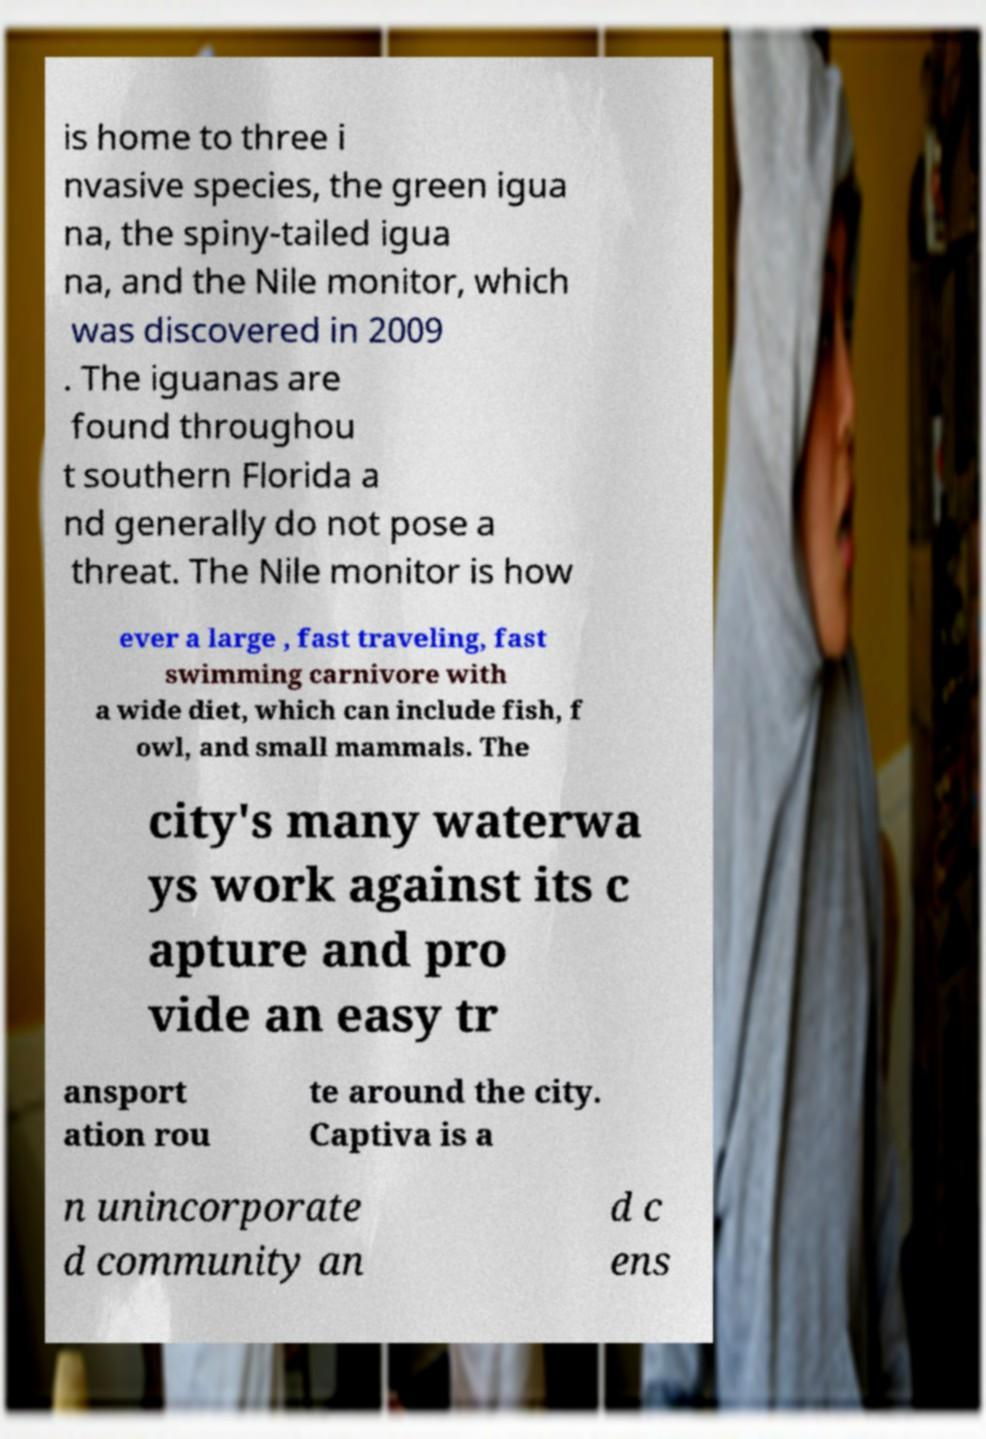For documentation purposes, I need the text within this image transcribed. Could you provide that? is home to three i nvasive species, the green igua na, the spiny-tailed igua na, and the Nile monitor, which was discovered in 2009 . The iguanas are found throughou t southern Florida a nd generally do not pose a threat. The Nile monitor is how ever a large , fast traveling, fast swimming carnivore with a wide diet, which can include fish, f owl, and small mammals. The city's many waterwa ys work against its c apture and pro vide an easy tr ansport ation rou te around the city. Captiva is a n unincorporate d community an d c ens 